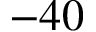<formula> <loc_0><loc_0><loc_500><loc_500>- 4 0</formula> 